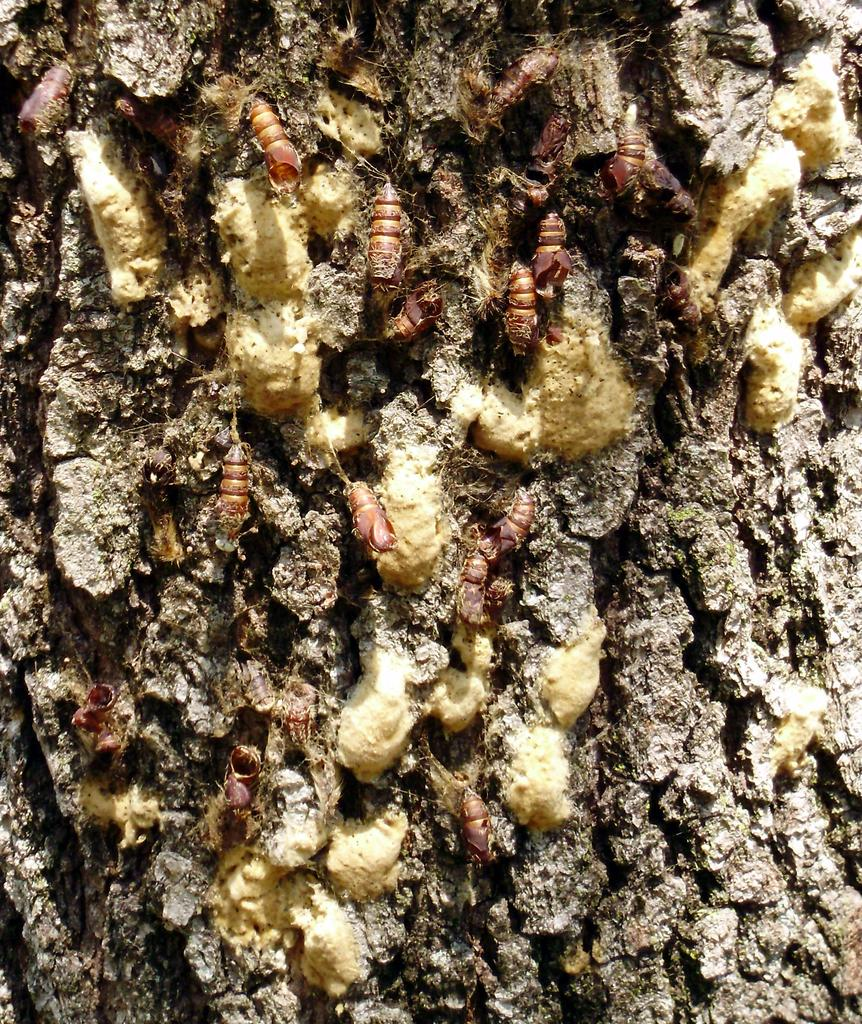What is the main subject of the image? The main subject of the image is a tree trunk. Are there any living organisms present on the tree trunk? Yes, there are insects on the tree trunk. What type of picture is hanging on the tree trunk in the image? There is no picture hanging on the tree trunk in the image; it only features a tree trunk and insects. 